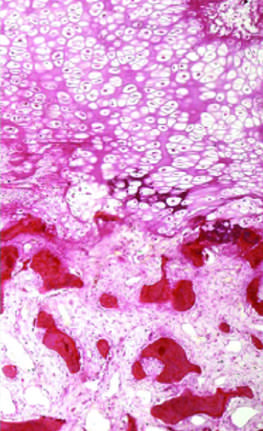do paler trabeculae consist of uncalcified osteoid?
Answer the question using a single word or phrase. Yes 